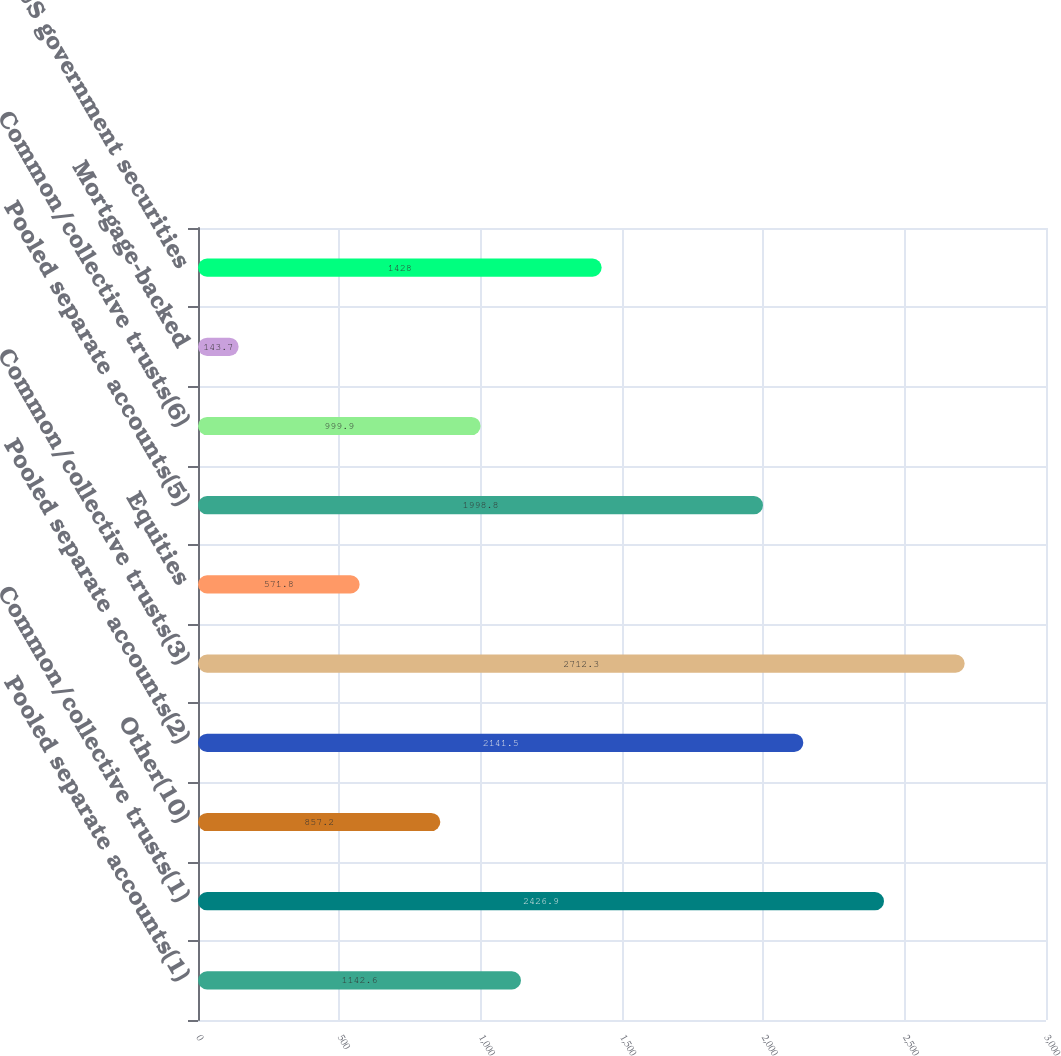<chart> <loc_0><loc_0><loc_500><loc_500><bar_chart><fcel>Pooled separate accounts(1)<fcel>Common/collective trusts(1)<fcel>Other(10)<fcel>Pooled separate accounts(2)<fcel>Common/collective trusts(3)<fcel>Equities<fcel>Pooled separate accounts(5)<fcel>Common/collective trusts(6)<fcel>Mortgage-backed<fcel>Other US government securities<nl><fcel>1142.6<fcel>2426.9<fcel>857.2<fcel>2141.5<fcel>2712.3<fcel>571.8<fcel>1998.8<fcel>999.9<fcel>143.7<fcel>1428<nl></chart> 